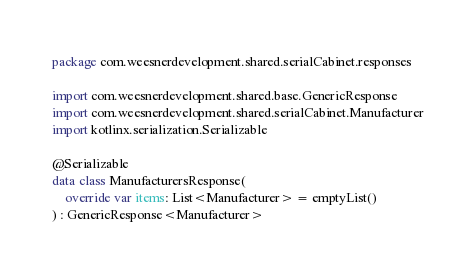<code> <loc_0><loc_0><loc_500><loc_500><_Kotlin_>package com.weesnerdevelopment.shared.serialCabinet.responses

import com.weesnerdevelopment.shared.base.GenericResponse
import com.weesnerdevelopment.shared.serialCabinet.Manufacturer
import kotlinx.serialization.Serializable

@Serializable
data class ManufacturersResponse(
    override var items: List<Manufacturer> = emptyList()
) : GenericResponse<Manufacturer></code> 